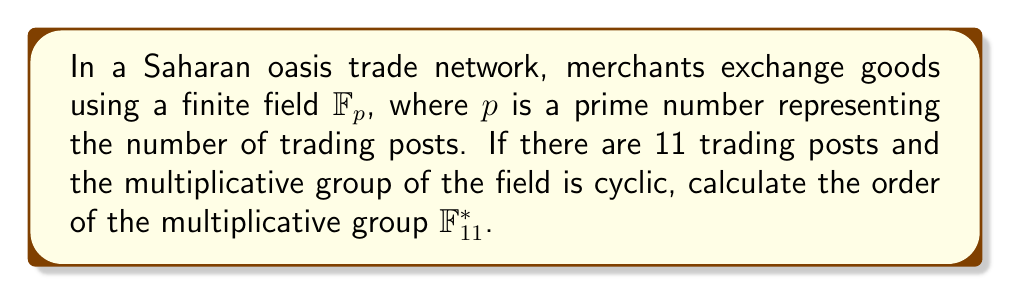Give your solution to this math problem. To solve this problem, we'll follow these steps:

1) In a finite field $\mathbb{F}_p$, where $p$ is prime, the order of the multiplicative group $\mathbb{F}_p^*$ is always $p - 1$.

2) In this case, we have 11 trading posts, so $p = 11$.

3) Therefore, the order of the multiplicative group $\mathbb{F}_{11}^*$ is:

   $$|\mathbb{F}_{11}^*| = 11 - 1 = 10$$

4) To verify, we can list all non-zero elements of $\mathbb{F}_{11}$:
   
   $\{1, 2, 3, 4, 5, 6, 7, 8, 9, 10\}$

5) Indeed, there are 10 elements in this set, confirming our calculation.

6) It's worth noting that $\mathbb{F}_{11}^*$ is cyclic, as stated in the question. This is true for all prime fields, but not necessarily for all finite fields in general.
Answer: $10$ 